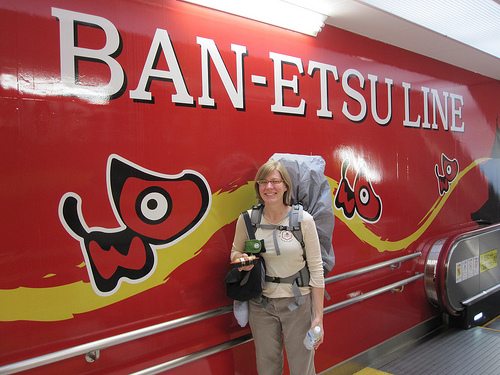<image>
Can you confirm if the dog is on the wall? Yes. Looking at the image, I can see the dog is positioned on top of the wall, with the wall providing support. Where is the wall in relation to the person? Is it next to the person? Yes. The wall is positioned adjacent to the person, located nearby in the same general area. 